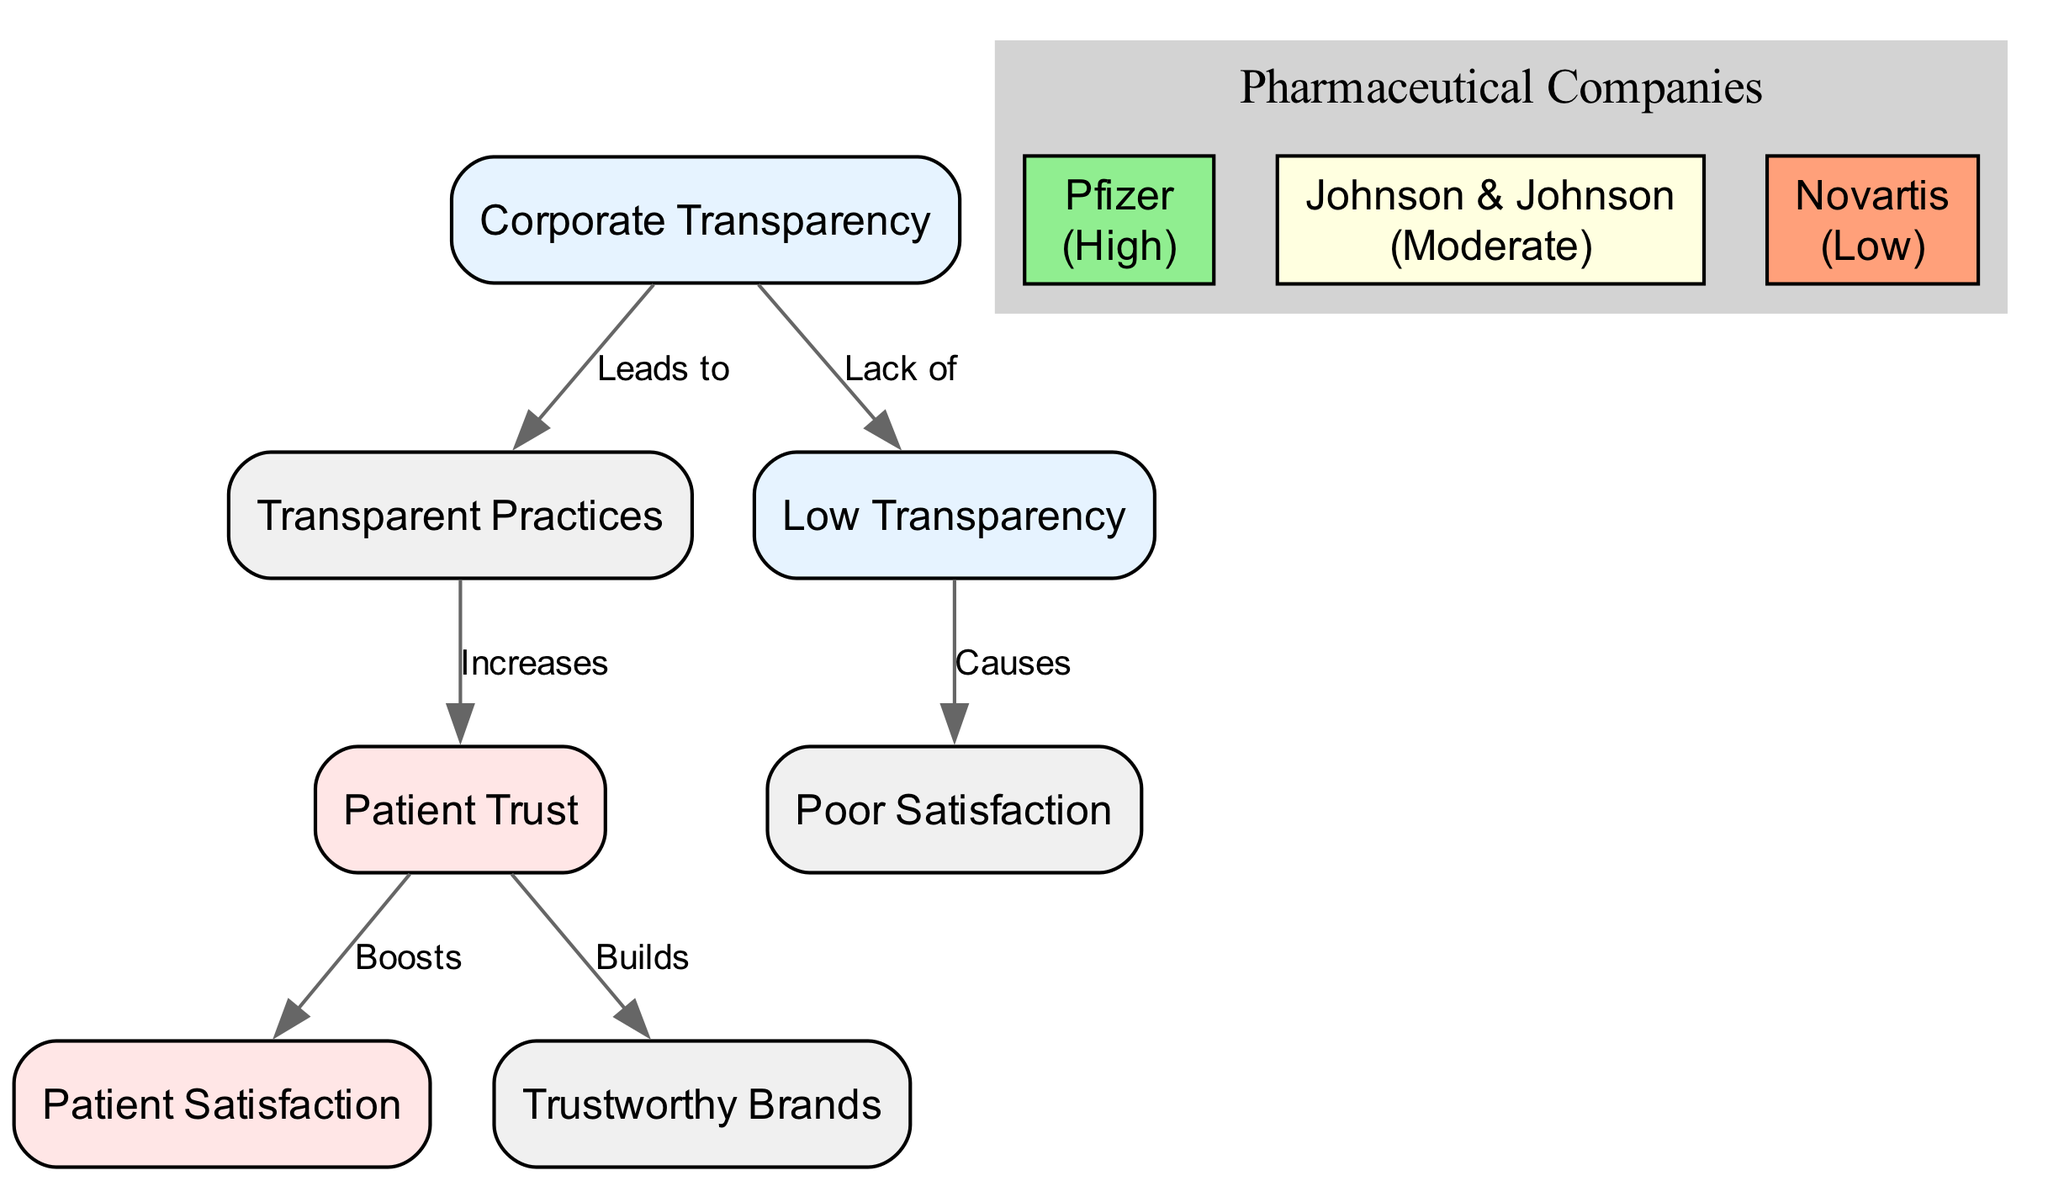What are the two main outcomes of high corporate transparency? The diagram shows that high corporate transparency leads to increased patient trust and ultimately boosts patient satisfaction. This is evidenced by the edges connecting "Corporate Transparency" to "Transparent Practices" and then further to "Patient Trust," which connects to "Patient Satisfaction."
Answer: Increased patient trust, boosts patient satisfaction How many nodes are present in the diagram? The diagram contains six nodes: "Corporate Transparency," "Patient Trust," "Patient Satisfaction," "Transparent Practices," "Trustworthy Brands," and "Low Transparency."
Answer: Six What does low transparency cause? The edge from "Low Transparency" points to "Poor Satisfaction," indicating that low transparency leads to poor satisfaction among patients.
Answer: Poor Satisfaction Which company is categorized with high transparency? According to the entities in the diagram, "Pfizer" is identified as having high transparency.
Answer: Pfizer What is the relationship between patient trust and trustworthy brands? The diagram illustrates that patient trust builds trustworthy brands, demonstrated by the directed edge from "Patient Trust" to "Trustworthy Brands."
Answer: Builds What color represents low transparency in the diagram? In the diagram, low transparency, represented by the node "Low Transparency," is colored to imply a negative aspect, which in this case is a warm color indicating decreased perception health, like light orange.
Answer: Light orange How many edges are present in the diagram? There are six directed edges in the diagram, representing various relationships among the nodes. Each edge represents a distinct connection as outlined in the data structure.
Answer: Six Which practice increases patient trust? The diagram indicates that "Transparent Practices" are the practices that increase patient trust, as shown by the connection from "Transparent Practices" to "Patient Trust."
Answer: Transparent Practices What does the lack of corporate transparency lead to? The lack of corporate transparency is linked to low transparency, which ultimately causes poor satisfaction as per the edges shown in the diagram.
Answer: Causes poor satisfaction 